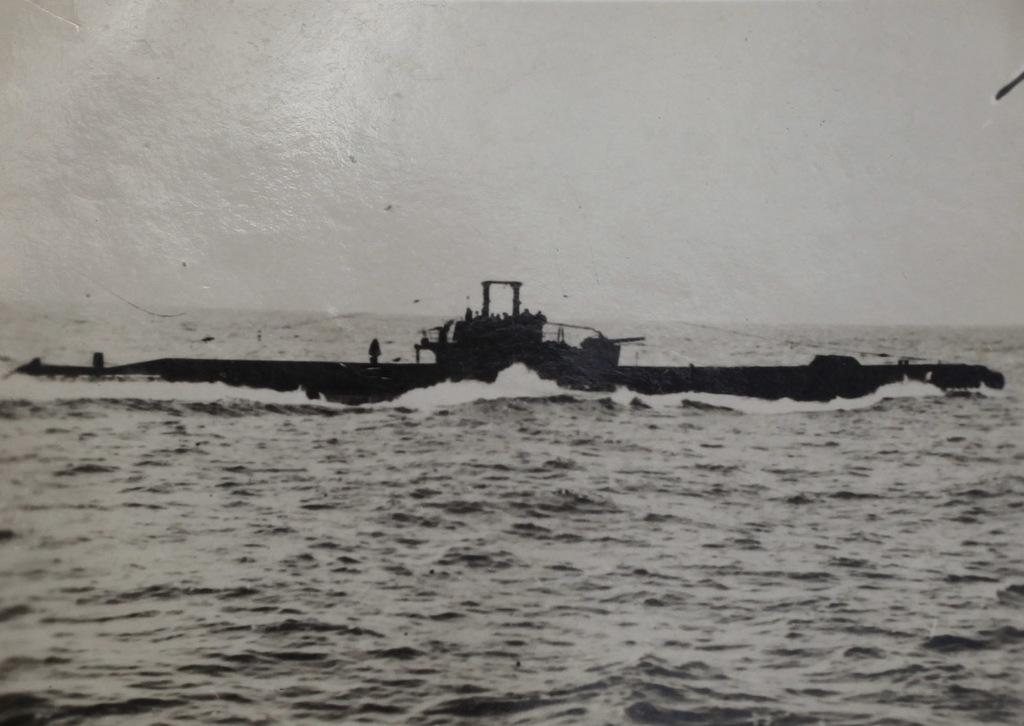What is the main subject of the image? The main subject of the image is a boat. Where is the boat located in the image? The boat is on the water surface in the image. What is the color scheme of the image? The image is in black and white color. Can you see any beans floating in the water near the boat? There are no beans visible in the image; it only features a boat on the water surface in black and white. 